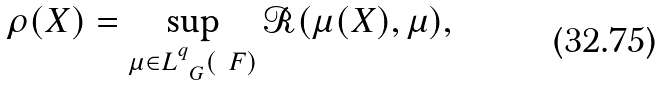Convert formula to latex. <formula><loc_0><loc_0><loc_500><loc_500>\rho ( X ) = \sup _ { \mu \in L ^ { q } _ { \ G } ( \ F ) } \mathcal { R } ( \mu ( X ) , \mu ) ,</formula> 